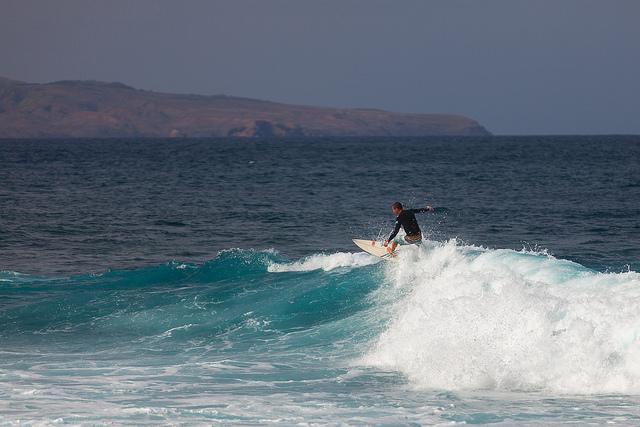How many people are surfing?
Quick response, please. 1. What is this man doing on the water?
Keep it brief. Surfing. How many people are in this picture?
Give a very brief answer. 1. Are the waves high?
Write a very short answer. Yes. Is this close to the shore?
Write a very short answer. No. Is the ocean calm?
Keep it brief. No. What is he doing?
Keep it brief. Surfing. Is any land shown?
Short answer required. Yes. Where is the boat?
Answer briefly. Water. Is the surfer shirtless?
Quick response, please. No. How many water vehicles are there?
Be succinct. 0. 